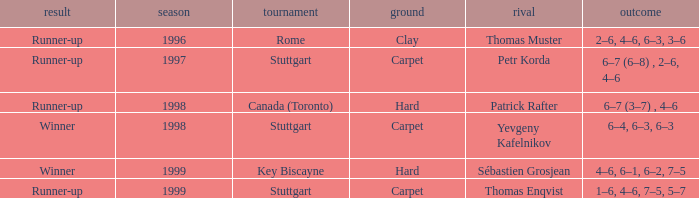What was the outcome before 1997? Runner-up. Would you mind parsing the complete table? {'header': ['result', 'season', 'tournament', 'ground', 'rival', 'outcome'], 'rows': [['Runner-up', '1996', 'Rome', 'Clay', 'Thomas Muster', '2–6, 4–6, 6–3, 3–6'], ['Runner-up', '1997', 'Stuttgart', 'Carpet', 'Petr Korda', '6–7 (6–8) , 2–6, 4–6'], ['Runner-up', '1998', 'Canada (Toronto)', 'Hard', 'Patrick Rafter', '6–7 (3–7) , 4–6'], ['Winner', '1998', 'Stuttgart', 'Carpet', 'Yevgeny Kafelnikov', '6–4, 6–3, 6–3'], ['Winner', '1999', 'Key Biscayne', 'Hard', 'Sébastien Grosjean', '4–6, 6–1, 6–2, 7–5'], ['Runner-up', '1999', 'Stuttgart', 'Carpet', 'Thomas Enqvist', '1–6, 4–6, 7–5, 5–7']]} 